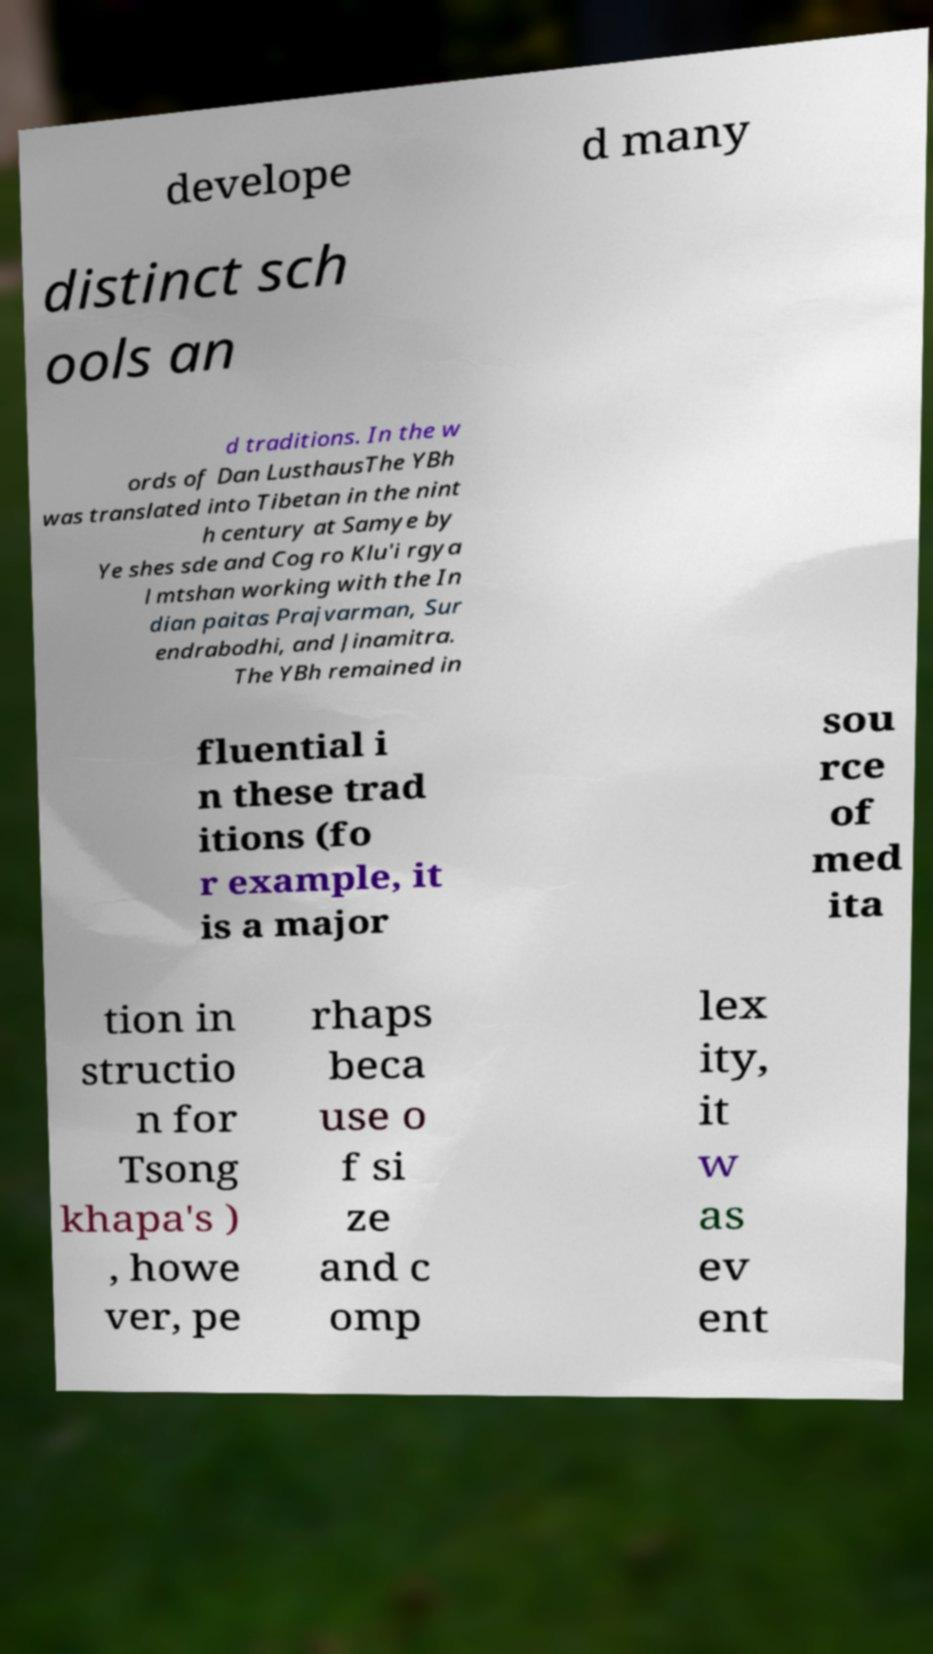I need the written content from this picture converted into text. Can you do that? develope d many distinct sch ools an d traditions. In the w ords of Dan LusthausThe YBh was translated into Tibetan in the nint h century at Samye by Ye shes sde and Cog ro Klu'i rgya l mtshan working with the In dian paitas Prajvarman, Sur endrabodhi, and Jinamitra. The YBh remained in fluential i n these trad itions (fo r example, it is a major sou rce of med ita tion in structio n for Tsong khapa's ) , howe ver, pe rhaps beca use o f si ze and c omp lex ity, it w as ev ent 